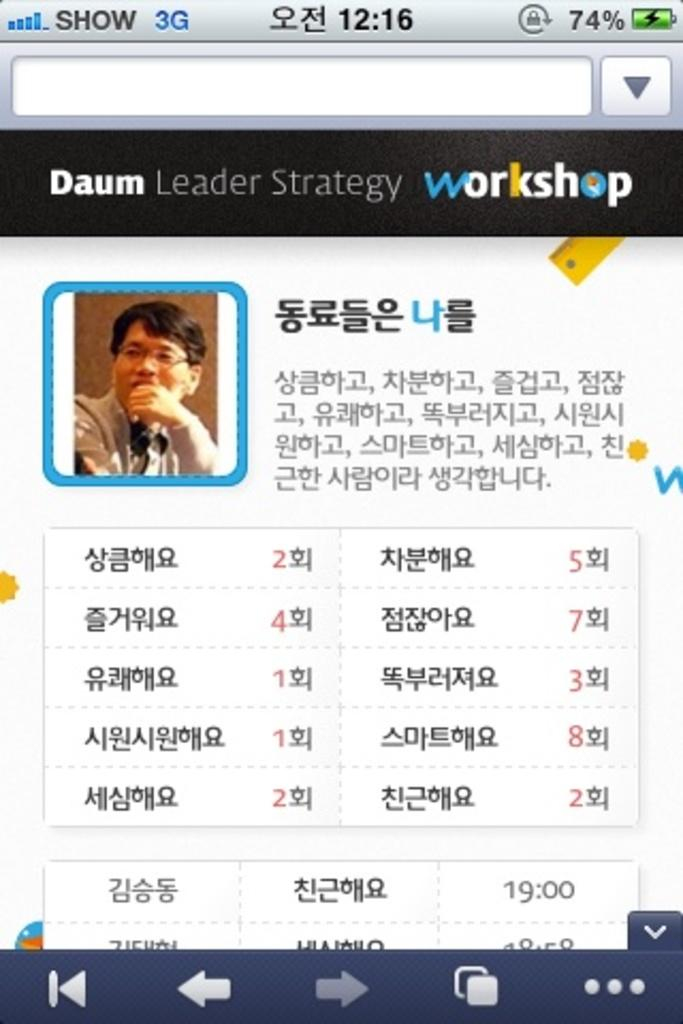What is the main subject of the web page? There is a man depicted on the web page. What else can be seen on the web page besides the man? There are symbols and text present on the web page. How many seeds are planted in the man's knee in the image? There is no mention of seeds or a knee in the image, as it only features a man, symbols, and text. 